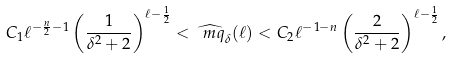Convert formula to latex. <formula><loc_0><loc_0><loc_500><loc_500>C _ { 1 } \ell ^ { - \frac { n } { 2 } - 1 } \left ( \frac { 1 } { \delta ^ { 2 } + 2 } \right ) ^ { \ell - \frac { 1 } { 2 } } < \widehat { \ m q } _ { \delta } ( \ell ) < C _ { 2 } \ell ^ { - 1 - n } \left ( \frac { 2 } { \delta ^ { 2 } + 2 } \right ) ^ { \ell - \frac { 1 } { 2 } } ,</formula> 